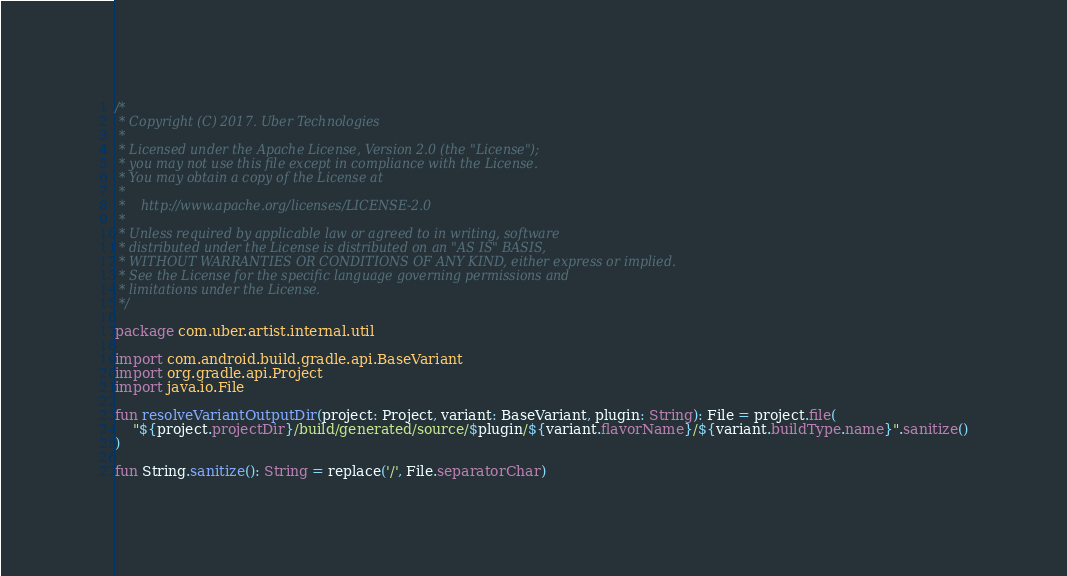<code> <loc_0><loc_0><loc_500><loc_500><_Kotlin_>/*
 * Copyright (C) 2017. Uber Technologies
 *
 * Licensed under the Apache License, Version 2.0 (the "License");
 * you may not use this file except in compliance with the License.
 * You may obtain a copy of the License at
 *
 *    http://www.apache.org/licenses/LICENSE-2.0
 *
 * Unless required by applicable law or agreed to in writing, software
 * distributed under the License is distributed on an "AS IS" BASIS,
 * WITHOUT WARRANTIES OR CONDITIONS OF ANY KIND, either express or implied.
 * See the License for the specific language governing permissions and
 * limitations under the License.
 */

package com.uber.artist.internal.util

import com.android.build.gradle.api.BaseVariant
import org.gradle.api.Project
import java.io.File

fun resolveVariantOutputDir(project: Project, variant: BaseVariant, plugin: String): File = project.file(
    "${project.projectDir}/build/generated/source/$plugin/${variant.flavorName}/${variant.buildType.name}".sanitize()
)

fun String.sanitize(): String = replace('/', File.separatorChar)
</code> 